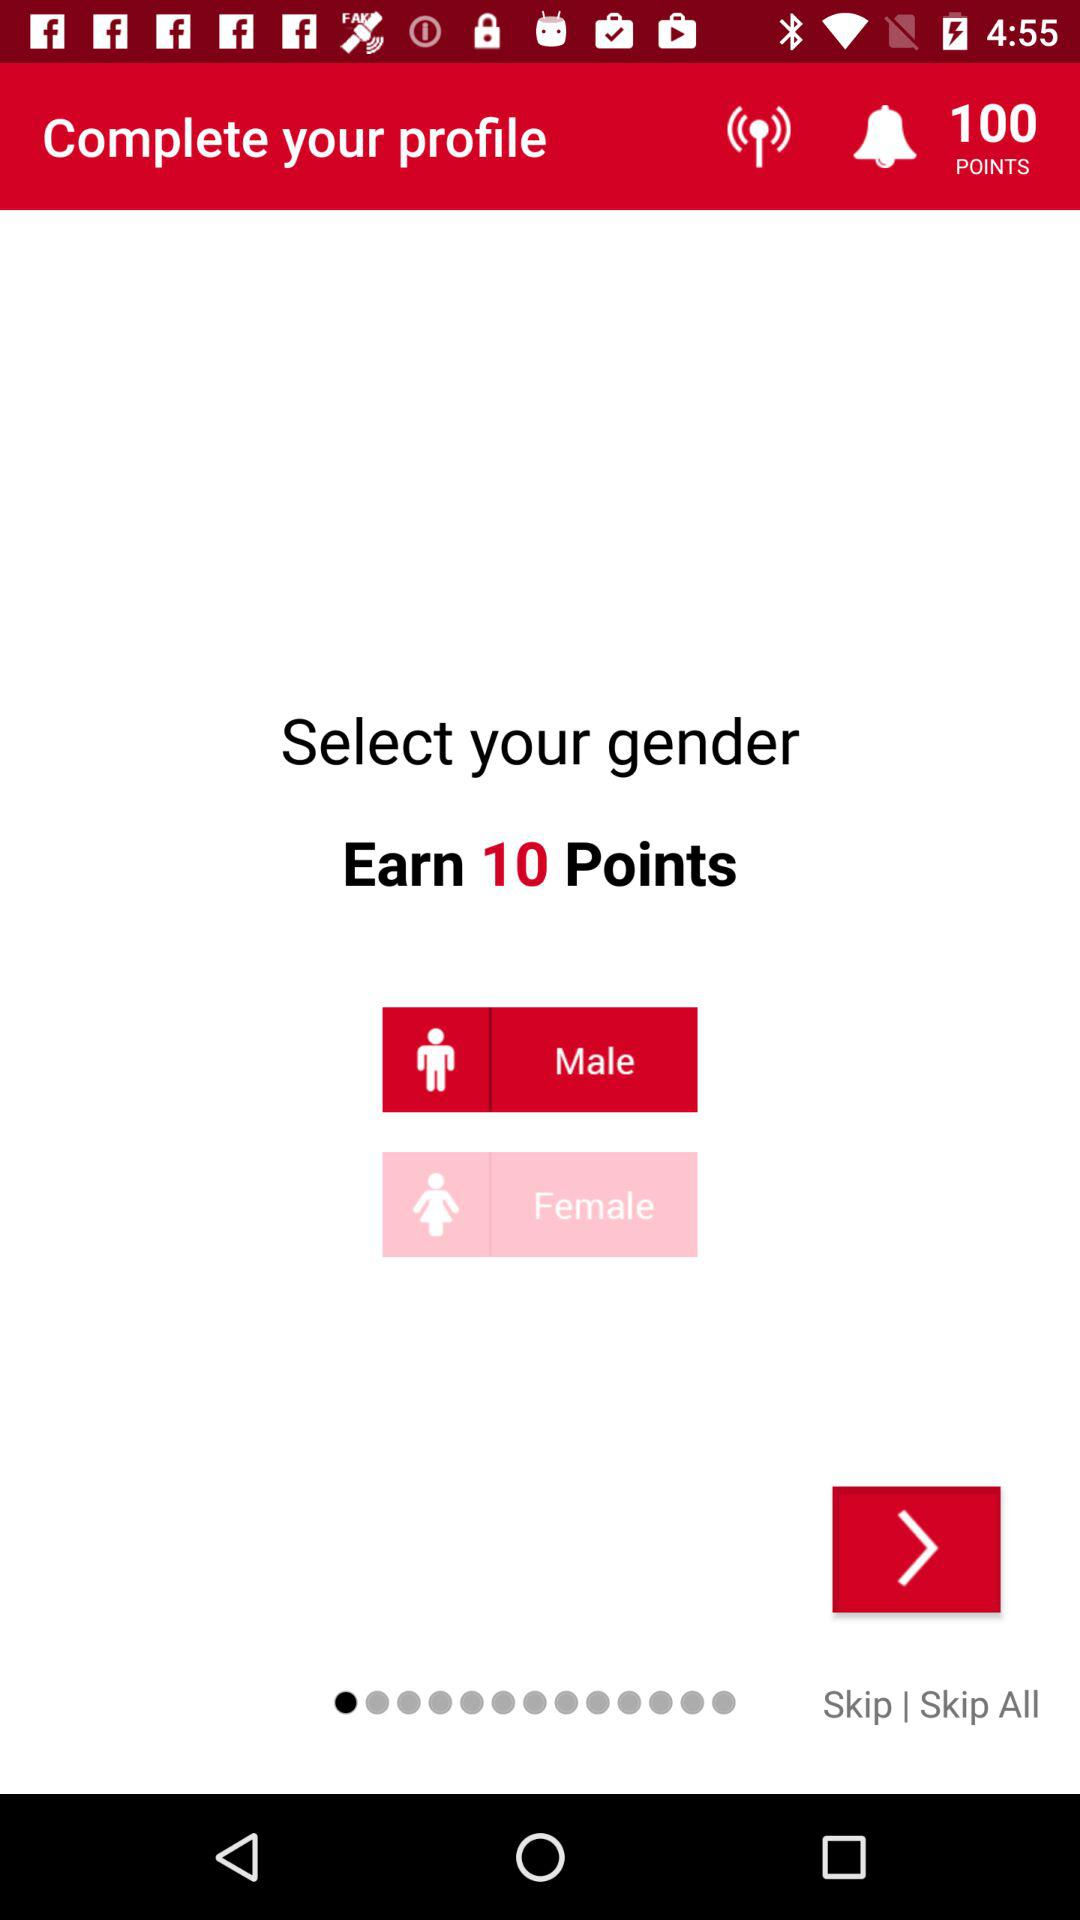How many points can I earn? You can earn 10 points. 